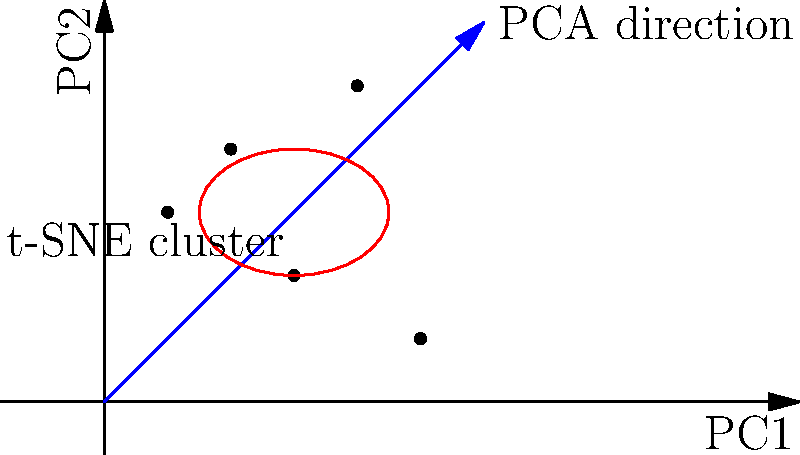Given the visualization of a high-dimensional dataset projected onto a 2D plane using Principal Component Analysis (PCA) and t-Distributed Stochastic Neighbor Embedding (t-SNE), which dimensionality reduction technique is more suitable for preserving local structure and identifying clusters in this dataset? To answer this question, let's analyze the characteristics of PCA and t-SNE:

1. PCA (Principal Component Analysis):
   - PCA is a linear dimensionality reduction technique.
   - It aims to find the directions (principal components) of maximum variance in the dataset.
   - In the visualization, the blue arrow represents the primary PCA direction.
   - PCA is good at preserving global structure and overall variance.

2. t-SNE (t-Distributed Stochastic Neighbor Embedding):
   - t-SNE is a non-linear dimensionality reduction technique.
   - It focuses on preserving local relationships between data points.
   - In the visualization, the red ellipse represents a cluster identified by t-SNE.
   - t-SNE is particularly effective at revealing clusters and local patterns.

3. Comparison for this dataset:
   - The data points seem to form a cluster (red ellipse) that is not aligned with the PCA direction.
   - t-SNE has successfully identified this cluster, which is not apparent from the PCA projection alone.
   - The local structure (proximity of points within the cluster) is better preserved by t-SNE.

4. Conclusion:
   - For this dataset, t-SNE appears more suitable for preserving local structure and identifying clusters.
   - t-SNE's ability to capture non-linear relationships makes it more effective in revealing the underlying cluster structure that is not evident from the linear PCA projection.

Therefore, t-SNE is the more suitable technique for preserving local structure and identifying clusters in this high-dimensional dataset visualization.
Answer: t-SNE 